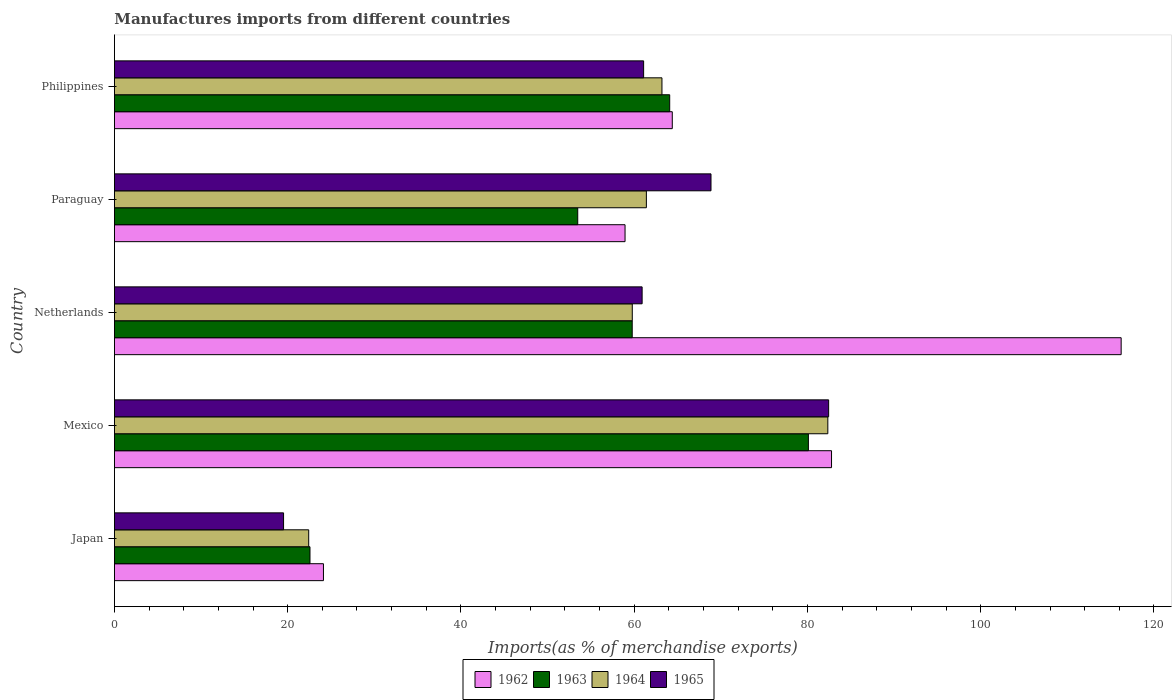Are the number of bars on each tick of the Y-axis equal?
Your response must be concise. Yes. How many bars are there on the 1st tick from the top?
Your response must be concise. 4. How many bars are there on the 1st tick from the bottom?
Offer a very short reply. 4. What is the label of the 3rd group of bars from the top?
Make the answer very short. Netherlands. In how many cases, is the number of bars for a given country not equal to the number of legend labels?
Ensure brevity in your answer.  0. What is the percentage of imports to different countries in 1963 in Mexico?
Give a very brief answer. 80.11. Across all countries, what is the maximum percentage of imports to different countries in 1964?
Offer a very short reply. 82.35. Across all countries, what is the minimum percentage of imports to different countries in 1964?
Provide a succinct answer. 22.43. What is the total percentage of imports to different countries in 1965 in the graph?
Offer a very short reply. 292.84. What is the difference between the percentage of imports to different countries in 1965 in Netherlands and that in Philippines?
Your response must be concise. -0.17. What is the difference between the percentage of imports to different countries in 1963 in Japan and the percentage of imports to different countries in 1962 in Mexico?
Provide a succinct answer. -60.2. What is the average percentage of imports to different countries in 1964 per country?
Your answer should be very brief. 57.83. What is the difference between the percentage of imports to different countries in 1965 and percentage of imports to different countries in 1964 in Japan?
Make the answer very short. -2.9. What is the ratio of the percentage of imports to different countries in 1964 in Mexico to that in Paraguay?
Give a very brief answer. 1.34. Is the difference between the percentage of imports to different countries in 1965 in Japan and Paraguay greater than the difference between the percentage of imports to different countries in 1964 in Japan and Paraguay?
Provide a succinct answer. No. What is the difference between the highest and the second highest percentage of imports to different countries in 1963?
Your answer should be compact. 16.01. What is the difference between the highest and the lowest percentage of imports to different countries in 1964?
Ensure brevity in your answer.  59.92. In how many countries, is the percentage of imports to different countries in 1962 greater than the average percentage of imports to different countries in 1962 taken over all countries?
Offer a terse response. 2. Is it the case that in every country, the sum of the percentage of imports to different countries in 1964 and percentage of imports to different countries in 1965 is greater than the sum of percentage of imports to different countries in 1963 and percentage of imports to different countries in 1962?
Provide a succinct answer. No. What does the 2nd bar from the top in Philippines represents?
Provide a short and direct response. 1964. What does the 1st bar from the bottom in Netherlands represents?
Make the answer very short. 1962. How many bars are there?
Your answer should be very brief. 20. How many countries are there in the graph?
Provide a succinct answer. 5. What is the difference between two consecutive major ticks on the X-axis?
Offer a terse response. 20. Does the graph contain any zero values?
Offer a terse response. No. Where does the legend appear in the graph?
Give a very brief answer. Bottom center. How many legend labels are there?
Your response must be concise. 4. How are the legend labels stacked?
Provide a short and direct response. Horizontal. What is the title of the graph?
Your answer should be very brief. Manufactures imports from different countries. Does "1964" appear as one of the legend labels in the graph?
Ensure brevity in your answer.  Yes. What is the label or title of the X-axis?
Your answer should be compact. Imports(as % of merchandise exports). What is the label or title of the Y-axis?
Your response must be concise. Country. What is the Imports(as % of merchandise exports) of 1962 in Japan?
Ensure brevity in your answer.  24.13. What is the Imports(as % of merchandise exports) of 1963 in Japan?
Your answer should be very brief. 22.57. What is the Imports(as % of merchandise exports) of 1964 in Japan?
Your answer should be very brief. 22.43. What is the Imports(as % of merchandise exports) of 1965 in Japan?
Provide a short and direct response. 19.52. What is the Imports(as % of merchandise exports) of 1962 in Mexico?
Your answer should be very brief. 82.78. What is the Imports(as % of merchandise exports) in 1963 in Mexico?
Your response must be concise. 80.11. What is the Imports(as % of merchandise exports) in 1964 in Mexico?
Your answer should be very brief. 82.35. What is the Imports(as % of merchandise exports) of 1965 in Mexico?
Provide a short and direct response. 82.44. What is the Imports(as % of merchandise exports) in 1962 in Netherlands?
Ensure brevity in your answer.  116.21. What is the Imports(as % of merchandise exports) of 1963 in Netherlands?
Keep it short and to the point. 59.77. What is the Imports(as % of merchandise exports) of 1964 in Netherlands?
Offer a very short reply. 59.78. What is the Imports(as % of merchandise exports) of 1965 in Netherlands?
Your response must be concise. 60.91. What is the Imports(as % of merchandise exports) in 1962 in Paraguay?
Your response must be concise. 58.94. What is the Imports(as % of merchandise exports) of 1963 in Paraguay?
Your answer should be compact. 53.48. What is the Imports(as % of merchandise exports) in 1964 in Paraguay?
Provide a short and direct response. 61.4. What is the Imports(as % of merchandise exports) in 1965 in Paraguay?
Give a very brief answer. 68.86. What is the Imports(as % of merchandise exports) of 1962 in Philippines?
Your response must be concise. 64.4. What is the Imports(as % of merchandise exports) of 1963 in Philippines?
Offer a very short reply. 64.1. What is the Imports(as % of merchandise exports) in 1964 in Philippines?
Give a very brief answer. 63.2. What is the Imports(as % of merchandise exports) of 1965 in Philippines?
Provide a succinct answer. 61.09. Across all countries, what is the maximum Imports(as % of merchandise exports) in 1962?
Provide a short and direct response. 116.21. Across all countries, what is the maximum Imports(as % of merchandise exports) in 1963?
Offer a terse response. 80.11. Across all countries, what is the maximum Imports(as % of merchandise exports) of 1964?
Make the answer very short. 82.35. Across all countries, what is the maximum Imports(as % of merchandise exports) in 1965?
Provide a short and direct response. 82.44. Across all countries, what is the minimum Imports(as % of merchandise exports) in 1962?
Your answer should be compact. 24.13. Across all countries, what is the minimum Imports(as % of merchandise exports) in 1963?
Provide a short and direct response. 22.57. Across all countries, what is the minimum Imports(as % of merchandise exports) of 1964?
Provide a succinct answer. 22.43. Across all countries, what is the minimum Imports(as % of merchandise exports) in 1965?
Your answer should be very brief. 19.52. What is the total Imports(as % of merchandise exports) in 1962 in the graph?
Give a very brief answer. 346.46. What is the total Imports(as % of merchandise exports) in 1963 in the graph?
Offer a very short reply. 280.03. What is the total Imports(as % of merchandise exports) of 1964 in the graph?
Provide a succinct answer. 289.16. What is the total Imports(as % of merchandise exports) of 1965 in the graph?
Make the answer very short. 292.84. What is the difference between the Imports(as % of merchandise exports) in 1962 in Japan and that in Mexico?
Keep it short and to the point. -58.65. What is the difference between the Imports(as % of merchandise exports) in 1963 in Japan and that in Mexico?
Keep it short and to the point. -57.53. What is the difference between the Imports(as % of merchandise exports) of 1964 in Japan and that in Mexico?
Provide a succinct answer. -59.92. What is the difference between the Imports(as % of merchandise exports) in 1965 in Japan and that in Mexico?
Provide a short and direct response. -62.92. What is the difference between the Imports(as % of merchandise exports) of 1962 in Japan and that in Netherlands?
Ensure brevity in your answer.  -92.08. What is the difference between the Imports(as % of merchandise exports) of 1963 in Japan and that in Netherlands?
Your answer should be very brief. -37.2. What is the difference between the Imports(as % of merchandise exports) of 1964 in Japan and that in Netherlands?
Your response must be concise. -37.35. What is the difference between the Imports(as % of merchandise exports) of 1965 in Japan and that in Netherlands?
Keep it short and to the point. -41.39. What is the difference between the Imports(as % of merchandise exports) in 1962 in Japan and that in Paraguay?
Your response must be concise. -34.81. What is the difference between the Imports(as % of merchandise exports) in 1963 in Japan and that in Paraguay?
Offer a very short reply. -30.91. What is the difference between the Imports(as % of merchandise exports) in 1964 in Japan and that in Paraguay?
Make the answer very short. -38.98. What is the difference between the Imports(as % of merchandise exports) of 1965 in Japan and that in Paraguay?
Offer a very short reply. -49.34. What is the difference between the Imports(as % of merchandise exports) of 1962 in Japan and that in Philippines?
Provide a succinct answer. -40.27. What is the difference between the Imports(as % of merchandise exports) in 1963 in Japan and that in Philippines?
Make the answer very short. -41.52. What is the difference between the Imports(as % of merchandise exports) in 1964 in Japan and that in Philippines?
Keep it short and to the point. -40.78. What is the difference between the Imports(as % of merchandise exports) of 1965 in Japan and that in Philippines?
Your response must be concise. -41.56. What is the difference between the Imports(as % of merchandise exports) of 1962 in Mexico and that in Netherlands?
Provide a short and direct response. -33.43. What is the difference between the Imports(as % of merchandise exports) in 1963 in Mexico and that in Netherlands?
Give a very brief answer. 20.34. What is the difference between the Imports(as % of merchandise exports) in 1964 in Mexico and that in Netherlands?
Keep it short and to the point. 22.57. What is the difference between the Imports(as % of merchandise exports) of 1965 in Mexico and that in Netherlands?
Keep it short and to the point. 21.53. What is the difference between the Imports(as % of merchandise exports) in 1962 in Mexico and that in Paraguay?
Keep it short and to the point. 23.83. What is the difference between the Imports(as % of merchandise exports) of 1963 in Mexico and that in Paraguay?
Provide a short and direct response. 26.63. What is the difference between the Imports(as % of merchandise exports) in 1964 in Mexico and that in Paraguay?
Provide a short and direct response. 20.95. What is the difference between the Imports(as % of merchandise exports) of 1965 in Mexico and that in Paraguay?
Make the answer very short. 13.58. What is the difference between the Imports(as % of merchandise exports) in 1962 in Mexico and that in Philippines?
Your answer should be compact. 18.38. What is the difference between the Imports(as % of merchandise exports) in 1963 in Mexico and that in Philippines?
Keep it short and to the point. 16.01. What is the difference between the Imports(as % of merchandise exports) of 1964 in Mexico and that in Philippines?
Give a very brief answer. 19.15. What is the difference between the Imports(as % of merchandise exports) in 1965 in Mexico and that in Philippines?
Make the answer very short. 21.36. What is the difference between the Imports(as % of merchandise exports) in 1962 in Netherlands and that in Paraguay?
Offer a very short reply. 57.27. What is the difference between the Imports(as % of merchandise exports) of 1963 in Netherlands and that in Paraguay?
Provide a succinct answer. 6.29. What is the difference between the Imports(as % of merchandise exports) in 1964 in Netherlands and that in Paraguay?
Provide a short and direct response. -1.63. What is the difference between the Imports(as % of merchandise exports) in 1965 in Netherlands and that in Paraguay?
Provide a short and direct response. -7.95. What is the difference between the Imports(as % of merchandise exports) in 1962 in Netherlands and that in Philippines?
Give a very brief answer. 51.81. What is the difference between the Imports(as % of merchandise exports) in 1963 in Netherlands and that in Philippines?
Provide a succinct answer. -4.33. What is the difference between the Imports(as % of merchandise exports) of 1964 in Netherlands and that in Philippines?
Your response must be concise. -3.42. What is the difference between the Imports(as % of merchandise exports) in 1965 in Netherlands and that in Philippines?
Offer a terse response. -0.17. What is the difference between the Imports(as % of merchandise exports) in 1962 in Paraguay and that in Philippines?
Your response must be concise. -5.45. What is the difference between the Imports(as % of merchandise exports) of 1963 in Paraguay and that in Philippines?
Make the answer very short. -10.62. What is the difference between the Imports(as % of merchandise exports) in 1964 in Paraguay and that in Philippines?
Provide a short and direct response. -1.8. What is the difference between the Imports(as % of merchandise exports) in 1965 in Paraguay and that in Philippines?
Your response must be concise. 7.78. What is the difference between the Imports(as % of merchandise exports) in 1962 in Japan and the Imports(as % of merchandise exports) in 1963 in Mexico?
Your answer should be very brief. -55.98. What is the difference between the Imports(as % of merchandise exports) of 1962 in Japan and the Imports(as % of merchandise exports) of 1964 in Mexico?
Offer a terse response. -58.22. What is the difference between the Imports(as % of merchandise exports) in 1962 in Japan and the Imports(as % of merchandise exports) in 1965 in Mexico?
Ensure brevity in your answer.  -58.32. What is the difference between the Imports(as % of merchandise exports) of 1963 in Japan and the Imports(as % of merchandise exports) of 1964 in Mexico?
Provide a short and direct response. -59.78. What is the difference between the Imports(as % of merchandise exports) of 1963 in Japan and the Imports(as % of merchandise exports) of 1965 in Mexico?
Keep it short and to the point. -59.87. What is the difference between the Imports(as % of merchandise exports) of 1964 in Japan and the Imports(as % of merchandise exports) of 1965 in Mexico?
Your answer should be very brief. -60.02. What is the difference between the Imports(as % of merchandise exports) in 1962 in Japan and the Imports(as % of merchandise exports) in 1963 in Netherlands?
Ensure brevity in your answer.  -35.64. What is the difference between the Imports(as % of merchandise exports) of 1962 in Japan and the Imports(as % of merchandise exports) of 1964 in Netherlands?
Offer a very short reply. -35.65. What is the difference between the Imports(as % of merchandise exports) of 1962 in Japan and the Imports(as % of merchandise exports) of 1965 in Netherlands?
Make the answer very short. -36.79. What is the difference between the Imports(as % of merchandise exports) of 1963 in Japan and the Imports(as % of merchandise exports) of 1964 in Netherlands?
Make the answer very short. -37.2. What is the difference between the Imports(as % of merchandise exports) in 1963 in Japan and the Imports(as % of merchandise exports) in 1965 in Netherlands?
Your answer should be very brief. -38.34. What is the difference between the Imports(as % of merchandise exports) in 1964 in Japan and the Imports(as % of merchandise exports) in 1965 in Netherlands?
Provide a succinct answer. -38.49. What is the difference between the Imports(as % of merchandise exports) of 1962 in Japan and the Imports(as % of merchandise exports) of 1963 in Paraguay?
Ensure brevity in your answer.  -29.35. What is the difference between the Imports(as % of merchandise exports) in 1962 in Japan and the Imports(as % of merchandise exports) in 1964 in Paraguay?
Your answer should be compact. -37.28. What is the difference between the Imports(as % of merchandise exports) in 1962 in Japan and the Imports(as % of merchandise exports) in 1965 in Paraguay?
Offer a very short reply. -44.74. What is the difference between the Imports(as % of merchandise exports) of 1963 in Japan and the Imports(as % of merchandise exports) of 1964 in Paraguay?
Offer a terse response. -38.83. What is the difference between the Imports(as % of merchandise exports) in 1963 in Japan and the Imports(as % of merchandise exports) in 1965 in Paraguay?
Ensure brevity in your answer.  -46.29. What is the difference between the Imports(as % of merchandise exports) of 1964 in Japan and the Imports(as % of merchandise exports) of 1965 in Paraguay?
Your response must be concise. -46.44. What is the difference between the Imports(as % of merchandise exports) of 1962 in Japan and the Imports(as % of merchandise exports) of 1963 in Philippines?
Make the answer very short. -39.97. What is the difference between the Imports(as % of merchandise exports) of 1962 in Japan and the Imports(as % of merchandise exports) of 1964 in Philippines?
Offer a very short reply. -39.07. What is the difference between the Imports(as % of merchandise exports) in 1962 in Japan and the Imports(as % of merchandise exports) in 1965 in Philippines?
Your answer should be compact. -36.96. What is the difference between the Imports(as % of merchandise exports) in 1963 in Japan and the Imports(as % of merchandise exports) in 1964 in Philippines?
Offer a very short reply. -40.63. What is the difference between the Imports(as % of merchandise exports) of 1963 in Japan and the Imports(as % of merchandise exports) of 1965 in Philippines?
Offer a terse response. -38.51. What is the difference between the Imports(as % of merchandise exports) in 1964 in Japan and the Imports(as % of merchandise exports) in 1965 in Philippines?
Keep it short and to the point. -38.66. What is the difference between the Imports(as % of merchandise exports) in 1962 in Mexico and the Imports(as % of merchandise exports) in 1963 in Netherlands?
Ensure brevity in your answer.  23.01. What is the difference between the Imports(as % of merchandise exports) of 1962 in Mexico and the Imports(as % of merchandise exports) of 1964 in Netherlands?
Provide a succinct answer. 23. What is the difference between the Imports(as % of merchandise exports) of 1962 in Mexico and the Imports(as % of merchandise exports) of 1965 in Netherlands?
Keep it short and to the point. 21.86. What is the difference between the Imports(as % of merchandise exports) in 1963 in Mexico and the Imports(as % of merchandise exports) in 1964 in Netherlands?
Your answer should be compact. 20.33. What is the difference between the Imports(as % of merchandise exports) in 1963 in Mexico and the Imports(as % of merchandise exports) in 1965 in Netherlands?
Keep it short and to the point. 19.19. What is the difference between the Imports(as % of merchandise exports) of 1964 in Mexico and the Imports(as % of merchandise exports) of 1965 in Netherlands?
Your answer should be very brief. 21.44. What is the difference between the Imports(as % of merchandise exports) of 1962 in Mexico and the Imports(as % of merchandise exports) of 1963 in Paraguay?
Offer a very short reply. 29.3. What is the difference between the Imports(as % of merchandise exports) in 1962 in Mexico and the Imports(as % of merchandise exports) in 1964 in Paraguay?
Make the answer very short. 21.37. What is the difference between the Imports(as % of merchandise exports) of 1962 in Mexico and the Imports(as % of merchandise exports) of 1965 in Paraguay?
Provide a succinct answer. 13.91. What is the difference between the Imports(as % of merchandise exports) in 1963 in Mexico and the Imports(as % of merchandise exports) in 1964 in Paraguay?
Your response must be concise. 18.7. What is the difference between the Imports(as % of merchandise exports) in 1963 in Mexico and the Imports(as % of merchandise exports) in 1965 in Paraguay?
Give a very brief answer. 11.24. What is the difference between the Imports(as % of merchandise exports) of 1964 in Mexico and the Imports(as % of merchandise exports) of 1965 in Paraguay?
Ensure brevity in your answer.  13.49. What is the difference between the Imports(as % of merchandise exports) in 1962 in Mexico and the Imports(as % of merchandise exports) in 1963 in Philippines?
Ensure brevity in your answer.  18.68. What is the difference between the Imports(as % of merchandise exports) in 1962 in Mexico and the Imports(as % of merchandise exports) in 1964 in Philippines?
Offer a terse response. 19.57. What is the difference between the Imports(as % of merchandise exports) of 1962 in Mexico and the Imports(as % of merchandise exports) of 1965 in Philippines?
Keep it short and to the point. 21.69. What is the difference between the Imports(as % of merchandise exports) in 1963 in Mexico and the Imports(as % of merchandise exports) in 1964 in Philippines?
Provide a succinct answer. 16.9. What is the difference between the Imports(as % of merchandise exports) of 1963 in Mexico and the Imports(as % of merchandise exports) of 1965 in Philippines?
Keep it short and to the point. 19.02. What is the difference between the Imports(as % of merchandise exports) in 1964 in Mexico and the Imports(as % of merchandise exports) in 1965 in Philippines?
Provide a succinct answer. 21.26. What is the difference between the Imports(as % of merchandise exports) in 1962 in Netherlands and the Imports(as % of merchandise exports) in 1963 in Paraguay?
Ensure brevity in your answer.  62.73. What is the difference between the Imports(as % of merchandise exports) of 1962 in Netherlands and the Imports(as % of merchandise exports) of 1964 in Paraguay?
Provide a succinct answer. 54.81. What is the difference between the Imports(as % of merchandise exports) of 1962 in Netherlands and the Imports(as % of merchandise exports) of 1965 in Paraguay?
Your response must be concise. 47.35. What is the difference between the Imports(as % of merchandise exports) in 1963 in Netherlands and the Imports(as % of merchandise exports) in 1964 in Paraguay?
Your answer should be very brief. -1.63. What is the difference between the Imports(as % of merchandise exports) of 1963 in Netherlands and the Imports(as % of merchandise exports) of 1965 in Paraguay?
Your response must be concise. -9.09. What is the difference between the Imports(as % of merchandise exports) in 1964 in Netherlands and the Imports(as % of merchandise exports) in 1965 in Paraguay?
Offer a terse response. -9.09. What is the difference between the Imports(as % of merchandise exports) in 1962 in Netherlands and the Imports(as % of merchandise exports) in 1963 in Philippines?
Provide a succinct answer. 52.11. What is the difference between the Imports(as % of merchandise exports) in 1962 in Netherlands and the Imports(as % of merchandise exports) in 1964 in Philippines?
Your answer should be compact. 53.01. What is the difference between the Imports(as % of merchandise exports) of 1962 in Netherlands and the Imports(as % of merchandise exports) of 1965 in Philippines?
Your answer should be compact. 55.12. What is the difference between the Imports(as % of merchandise exports) of 1963 in Netherlands and the Imports(as % of merchandise exports) of 1964 in Philippines?
Keep it short and to the point. -3.43. What is the difference between the Imports(as % of merchandise exports) in 1963 in Netherlands and the Imports(as % of merchandise exports) in 1965 in Philippines?
Ensure brevity in your answer.  -1.32. What is the difference between the Imports(as % of merchandise exports) in 1964 in Netherlands and the Imports(as % of merchandise exports) in 1965 in Philippines?
Ensure brevity in your answer.  -1.31. What is the difference between the Imports(as % of merchandise exports) in 1962 in Paraguay and the Imports(as % of merchandise exports) in 1963 in Philippines?
Your response must be concise. -5.15. What is the difference between the Imports(as % of merchandise exports) in 1962 in Paraguay and the Imports(as % of merchandise exports) in 1964 in Philippines?
Your response must be concise. -4.26. What is the difference between the Imports(as % of merchandise exports) of 1962 in Paraguay and the Imports(as % of merchandise exports) of 1965 in Philippines?
Give a very brief answer. -2.14. What is the difference between the Imports(as % of merchandise exports) in 1963 in Paraguay and the Imports(as % of merchandise exports) in 1964 in Philippines?
Your answer should be compact. -9.72. What is the difference between the Imports(as % of merchandise exports) of 1963 in Paraguay and the Imports(as % of merchandise exports) of 1965 in Philippines?
Offer a very short reply. -7.61. What is the difference between the Imports(as % of merchandise exports) in 1964 in Paraguay and the Imports(as % of merchandise exports) in 1965 in Philippines?
Offer a terse response. 0.32. What is the average Imports(as % of merchandise exports) in 1962 per country?
Give a very brief answer. 69.29. What is the average Imports(as % of merchandise exports) in 1963 per country?
Offer a very short reply. 56.01. What is the average Imports(as % of merchandise exports) in 1964 per country?
Make the answer very short. 57.83. What is the average Imports(as % of merchandise exports) of 1965 per country?
Your answer should be compact. 58.57. What is the difference between the Imports(as % of merchandise exports) of 1962 and Imports(as % of merchandise exports) of 1963 in Japan?
Give a very brief answer. 1.55. What is the difference between the Imports(as % of merchandise exports) in 1962 and Imports(as % of merchandise exports) in 1964 in Japan?
Give a very brief answer. 1.7. What is the difference between the Imports(as % of merchandise exports) of 1962 and Imports(as % of merchandise exports) of 1965 in Japan?
Your answer should be compact. 4.6. What is the difference between the Imports(as % of merchandise exports) of 1963 and Imports(as % of merchandise exports) of 1964 in Japan?
Your response must be concise. 0.15. What is the difference between the Imports(as % of merchandise exports) in 1963 and Imports(as % of merchandise exports) in 1965 in Japan?
Give a very brief answer. 3.05. What is the difference between the Imports(as % of merchandise exports) in 1964 and Imports(as % of merchandise exports) in 1965 in Japan?
Provide a short and direct response. 2.9. What is the difference between the Imports(as % of merchandise exports) of 1962 and Imports(as % of merchandise exports) of 1963 in Mexico?
Offer a very short reply. 2.67. What is the difference between the Imports(as % of merchandise exports) in 1962 and Imports(as % of merchandise exports) in 1964 in Mexico?
Offer a very short reply. 0.43. What is the difference between the Imports(as % of merchandise exports) of 1962 and Imports(as % of merchandise exports) of 1965 in Mexico?
Offer a very short reply. 0.33. What is the difference between the Imports(as % of merchandise exports) in 1963 and Imports(as % of merchandise exports) in 1964 in Mexico?
Offer a terse response. -2.24. What is the difference between the Imports(as % of merchandise exports) of 1963 and Imports(as % of merchandise exports) of 1965 in Mexico?
Your answer should be very brief. -2.34. What is the difference between the Imports(as % of merchandise exports) of 1964 and Imports(as % of merchandise exports) of 1965 in Mexico?
Give a very brief answer. -0.09. What is the difference between the Imports(as % of merchandise exports) of 1962 and Imports(as % of merchandise exports) of 1963 in Netherlands?
Ensure brevity in your answer.  56.44. What is the difference between the Imports(as % of merchandise exports) of 1962 and Imports(as % of merchandise exports) of 1964 in Netherlands?
Make the answer very short. 56.43. What is the difference between the Imports(as % of merchandise exports) of 1962 and Imports(as % of merchandise exports) of 1965 in Netherlands?
Make the answer very short. 55.3. What is the difference between the Imports(as % of merchandise exports) of 1963 and Imports(as % of merchandise exports) of 1964 in Netherlands?
Keep it short and to the point. -0.01. What is the difference between the Imports(as % of merchandise exports) in 1963 and Imports(as % of merchandise exports) in 1965 in Netherlands?
Give a very brief answer. -1.14. What is the difference between the Imports(as % of merchandise exports) in 1964 and Imports(as % of merchandise exports) in 1965 in Netherlands?
Your answer should be very brief. -1.14. What is the difference between the Imports(as % of merchandise exports) of 1962 and Imports(as % of merchandise exports) of 1963 in Paraguay?
Give a very brief answer. 5.46. What is the difference between the Imports(as % of merchandise exports) of 1962 and Imports(as % of merchandise exports) of 1964 in Paraguay?
Your answer should be compact. -2.46. What is the difference between the Imports(as % of merchandise exports) in 1962 and Imports(as % of merchandise exports) in 1965 in Paraguay?
Offer a terse response. -9.92. What is the difference between the Imports(as % of merchandise exports) in 1963 and Imports(as % of merchandise exports) in 1964 in Paraguay?
Make the answer very short. -7.92. What is the difference between the Imports(as % of merchandise exports) of 1963 and Imports(as % of merchandise exports) of 1965 in Paraguay?
Your response must be concise. -15.38. What is the difference between the Imports(as % of merchandise exports) of 1964 and Imports(as % of merchandise exports) of 1965 in Paraguay?
Ensure brevity in your answer.  -7.46. What is the difference between the Imports(as % of merchandise exports) of 1962 and Imports(as % of merchandise exports) of 1963 in Philippines?
Your answer should be very brief. 0.3. What is the difference between the Imports(as % of merchandise exports) in 1962 and Imports(as % of merchandise exports) in 1964 in Philippines?
Your answer should be very brief. 1.19. What is the difference between the Imports(as % of merchandise exports) of 1962 and Imports(as % of merchandise exports) of 1965 in Philippines?
Your answer should be very brief. 3.31. What is the difference between the Imports(as % of merchandise exports) of 1963 and Imports(as % of merchandise exports) of 1964 in Philippines?
Your answer should be compact. 0.89. What is the difference between the Imports(as % of merchandise exports) of 1963 and Imports(as % of merchandise exports) of 1965 in Philippines?
Make the answer very short. 3.01. What is the difference between the Imports(as % of merchandise exports) of 1964 and Imports(as % of merchandise exports) of 1965 in Philippines?
Ensure brevity in your answer.  2.12. What is the ratio of the Imports(as % of merchandise exports) of 1962 in Japan to that in Mexico?
Your answer should be very brief. 0.29. What is the ratio of the Imports(as % of merchandise exports) in 1963 in Japan to that in Mexico?
Ensure brevity in your answer.  0.28. What is the ratio of the Imports(as % of merchandise exports) in 1964 in Japan to that in Mexico?
Offer a very short reply. 0.27. What is the ratio of the Imports(as % of merchandise exports) of 1965 in Japan to that in Mexico?
Provide a succinct answer. 0.24. What is the ratio of the Imports(as % of merchandise exports) of 1962 in Japan to that in Netherlands?
Keep it short and to the point. 0.21. What is the ratio of the Imports(as % of merchandise exports) of 1963 in Japan to that in Netherlands?
Provide a succinct answer. 0.38. What is the ratio of the Imports(as % of merchandise exports) in 1964 in Japan to that in Netherlands?
Your answer should be compact. 0.38. What is the ratio of the Imports(as % of merchandise exports) of 1965 in Japan to that in Netherlands?
Provide a short and direct response. 0.32. What is the ratio of the Imports(as % of merchandise exports) of 1962 in Japan to that in Paraguay?
Ensure brevity in your answer.  0.41. What is the ratio of the Imports(as % of merchandise exports) in 1963 in Japan to that in Paraguay?
Make the answer very short. 0.42. What is the ratio of the Imports(as % of merchandise exports) of 1964 in Japan to that in Paraguay?
Offer a terse response. 0.37. What is the ratio of the Imports(as % of merchandise exports) of 1965 in Japan to that in Paraguay?
Provide a succinct answer. 0.28. What is the ratio of the Imports(as % of merchandise exports) in 1962 in Japan to that in Philippines?
Provide a succinct answer. 0.37. What is the ratio of the Imports(as % of merchandise exports) in 1963 in Japan to that in Philippines?
Make the answer very short. 0.35. What is the ratio of the Imports(as % of merchandise exports) of 1964 in Japan to that in Philippines?
Offer a terse response. 0.35. What is the ratio of the Imports(as % of merchandise exports) of 1965 in Japan to that in Philippines?
Your answer should be very brief. 0.32. What is the ratio of the Imports(as % of merchandise exports) of 1962 in Mexico to that in Netherlands?
Make the answer very short. 0.71. What is the ratio of the Imports(as % of merchandise exports) in 1963 in Mexico to that in Netherlands?
Offer a terse response. 1.34. What is the ratio of the Imports(as % of merchandise exports) in 1964 in Mexico to that in Netherlands?
Make the answer very short. 1.38. What is the ratio of the Imports(as % of merchandise exports) of 1965 in Mexico to that in Netherlands?
Keep it short and to the point. 1.35. What is the ratio of the Imports(as % of merchandise exports) in 1962 in Mexico to that in Paraguay?
Offer a very short reply. 1.4. What is the ratio of the Imports(as % of merchandise exports) of 1963 in Mexico to that in Paraguay?
Offer a terse response. 1.5. What is the ratio of the Imports(as % of merchandise exports) of 1964 in Mexico to that in Paraguay?
Provide a succinct answer. 1.34. What is the ratio of the Imports(as % of merchandise exports) in 1965 in Mexico to that in Paraguay?
Make the answer very short. 1.2. What is the ratio of the Imports(as % of merchandise exports) in 1962 in Mexico to that in Philippines?
Offer a terse response. 1.29. What is the ratio of the Imports(as % of merchandise exports) of 1963 in Mexico to that in Philippines?
Offer a terse response. 1.25. What is the ratio of the Imports(as % of merchandise exports) in 1964 in Mexico to that in Philippines?
Provide a succinct answer. 1.3. What is the ratio of the Imports(as % of merchandise exports) of 1965 in Mexico to that in Philippines?
Make the answer very short. 1.35. What is the ratio of the Imports(as % of merchandise exports) of 1962 in Netherlands to that in Paraguay?
Make the answer very short. 1.97. What is the ratio of the Imports(as % of merchandise exports) in 1963 in Netherlands to that in Paraguay?
Keep it short and to the point. 1.12. What is the ratio of the Imports(as % of merchandise exports) in 1964 in Netherlands to that in Paraguay?
Provide a short and direct response. 0.97. What is the ratio of the Imports(as % of merchandise exports) in 1965 in Netherlands to that in Paraguay?
Your answer should be very brief. 0.88. What is the ratio of the Imports(as % of merchandise exports) of 1962 in Netherlands to that in Philippines?
Your answer should be compact. 1.8. What is the ratio of the Imports(as % of merchandise exports) of 1963 in Netherlands to that in Philippines?
Make the answer very short. 0.93. What is the ratio of the Imports(as % of merchandise exports) of 1964 in Netherlands to that in Philippines?
Provide a succinct answer. 0.95. What is the ratio of the Imports(as % of merchandise exports) of 1962 in Paraguay to that in Philippines?
Offer a terse response. 0.92. What is the ratio of the Imports(as % of merchandise exports) in 1963 in Paraguay to that in Philippines?
Provide a short and direct response. 0.83. What is the ratio of the Imports(as % of merchandise exports) in 1964 in Paraguay to that in Philippines?
Your answer should be very brief. 0.97. What is the ratio of the Imports(as % of merchandise exports) of 1965 in Paraguay to that in Philippines?
Ensure brevity in your answer.  1.13. What is the difference between the highest and the second highest Imports(as % of merchandise exports) of 1962?
Provide a succinct answer. 33.43. What is the difference between the highest and the second highest Imports(as % of merchandise exports) of 1963?
Provide a succinct answer. 16.01. What is the difference between the highest and the second highest Imports(as % of merchandise exports) of 1964?
Your answer should be compact. 19.15. What is the difference between the highest and the second highest Imports(as % of merchandise exports) in 1965?
Keep it short and to the point. 13.58. What is the difference between the highest and the lowest Imports(as % of merchandise exports) in 1962?
Your answer should be compact. 92.08. What is the difference between the highest and the lowest Imports(as % of merchandise exports) in 1963?
Make the answer very short. 57.53. What is the difference between the highest and the lowest Imports(as % of merchandise exports) of 1964?
Make the answer very short. 59.92. What is the difference between the highest and the lowest Imports(as % of merchandise exports) of 1965?
Offer a very short reply. 62.92. 